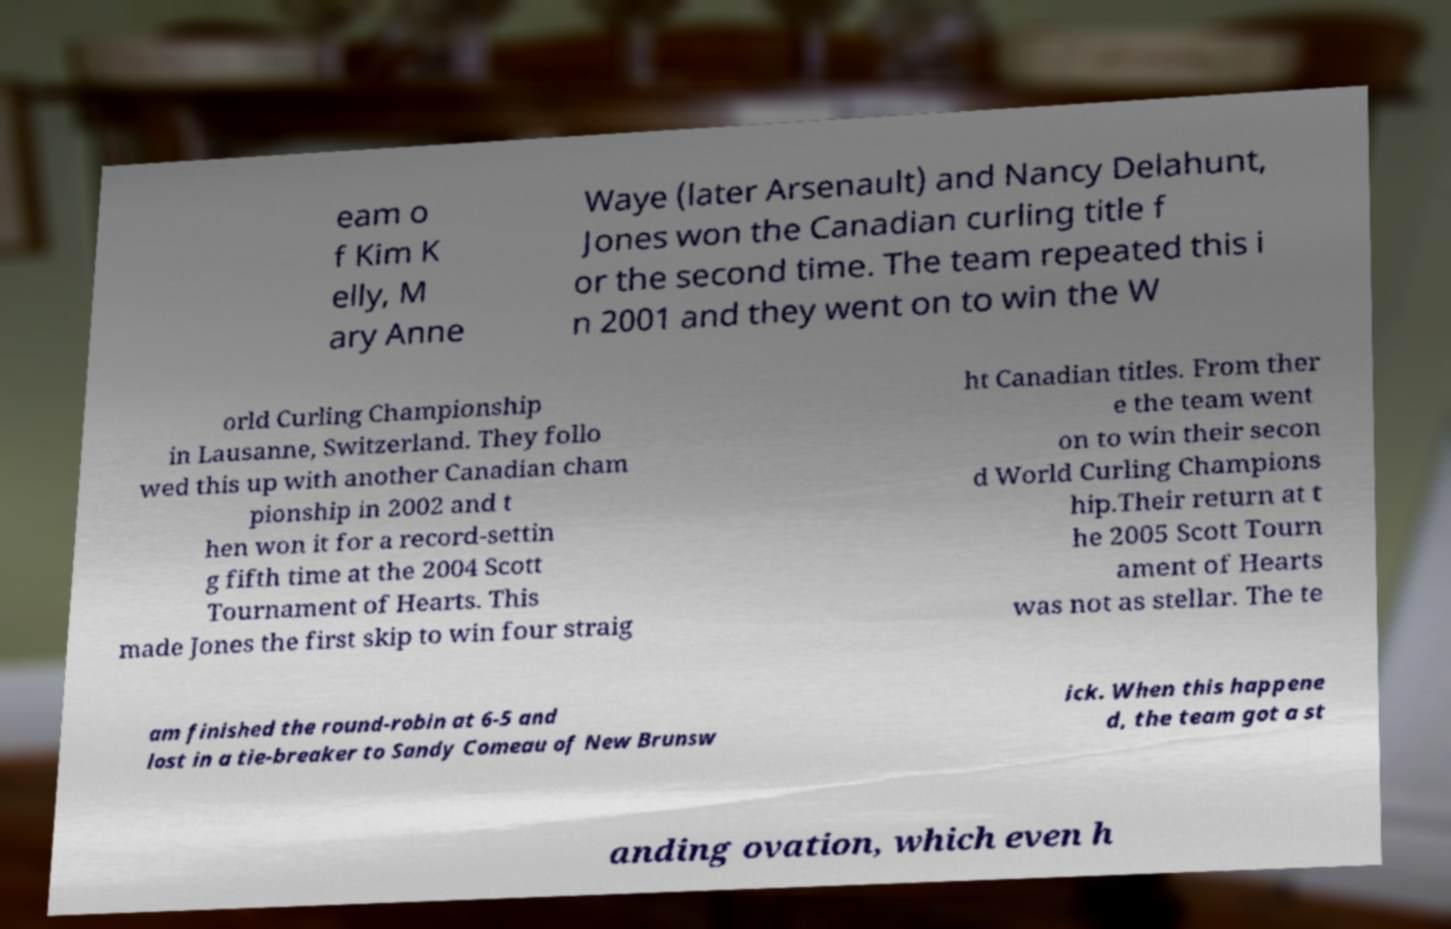I need the written content from this picture converted into text. Can you do that? eam o f Kim K elly, M ary Anne Waye (later Arsenault) and Nancy Delahunt, Jones won the Canadian curling title f or the second time. The team repeated this i n 2001 and they went on to win the W orld Curling Championship in Lausanne, Switzerland. They follo wed this up with another Canadian cham pionship in 2002 and t hen won it for a record-settin g fifth time at the 2004 Scott Tournament of Hearts. This made Jones the first skip to win four straig ht Canadian titles. From ther e the team went on to win their secon d World Curling Champions hip.Their return at t he 2005 Scott Tourn ament of Hearts was not as stellar. The te am finished the round-robin at 6-5 and lost in a tie-breaker to Sandy Comeau of New Brunsw ick. When this happene d, the team got a st anding ovation, which even h 